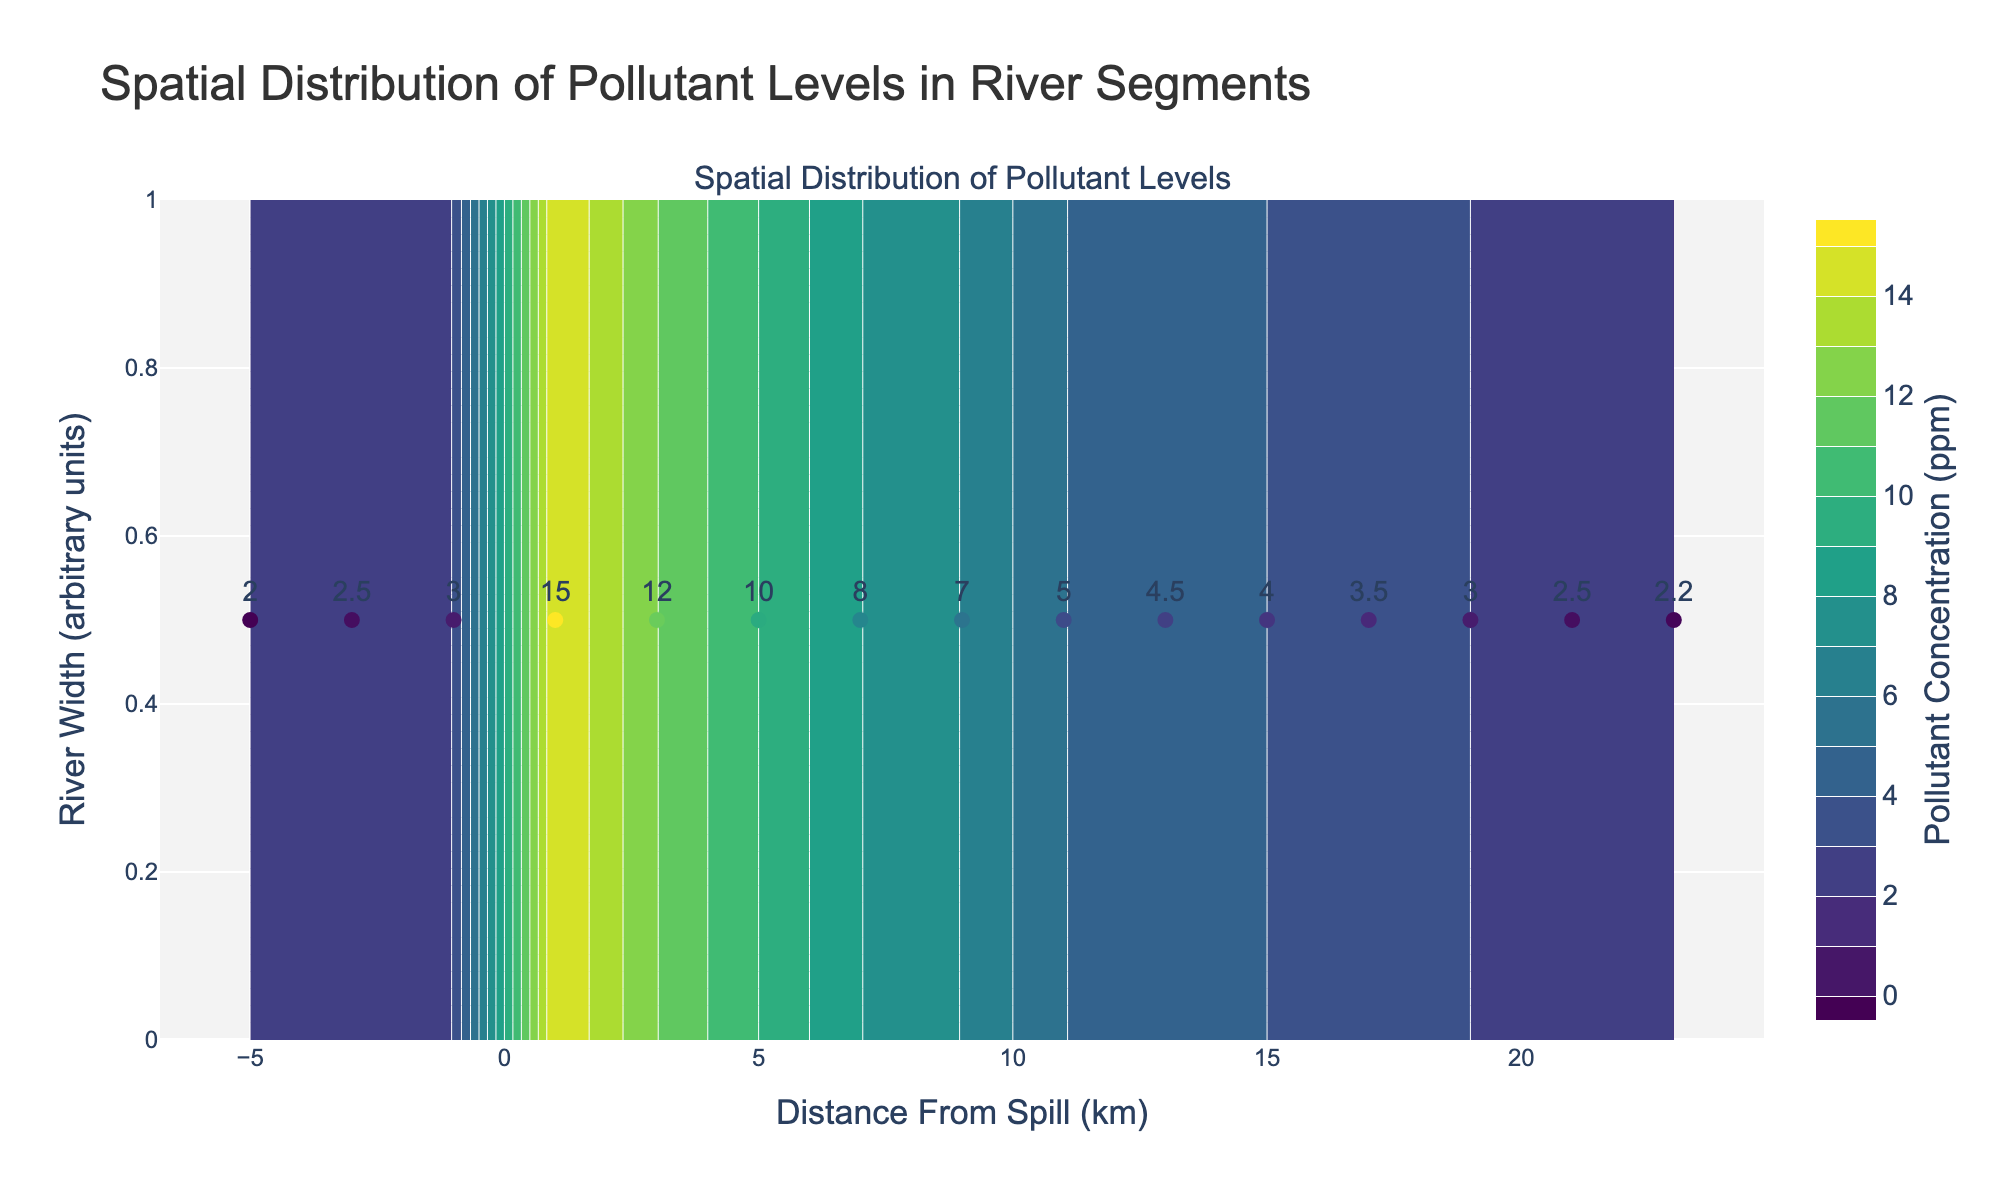What's the title of the plot? The title is prominently displayed at the top of the figure.
Answer: Spatial Distribution of Pollutant Levels in River Segments What is the highest pollutant concentration labelled in the figure? The highest labelled pollutant concentration can be identified by checking the text labels on the scatter plot points.
Answer: 15 ppm Where is the spill location marked on the plot? The spill location is indicated by the annotation near the center and top of the x-axis with the label 'Spill Location' and an arrow pointing to the corresponding location on the plot.
Answer: At 0 km How does the pollutant concentration change as the distance from the spill increases? Observing the scatter points and contour lines, the pollutant concentration decreases as the distance from the spill increases.
Answer: Decreases Which data point has the lowest pollutant concentration downstream? The data points downstream can be identified by their position to the right of the spill. The lowest label among these points indicates the lowest concentration.
Answer: Downstream_12 Comparing data points at distances -5 km, 3 km, and 15 km, which has the highest pollutant concentration? Checking the labelled values of the points at -5 km (Upstream_1: 2 ppm), 3 km (Downstream_2: 12 ppm), and 15 km (Downstream_8: 4 ppm), the highest concentration is at 3 km.
Answer: 3 km At what distance from the spill does the pollutant concentration drop below 5 ppm? By examining the scatter plot labels and interpolated contour lines, we note that the concentration drops below 5 ppm between 11 km and 15 km downstream from the spill.
Answer: 11-15 km What is the range of pollutant concentrations represented by the color gradient in the contour plot? The color gradient in the contour plot, as indicated by the colorbar, ranges from the lowest concentration to the highest concentration.
Answer: 0 ppm to 15 ppm Which segment, upstream or downstream, shows higher pollutant concentrations overall? Looking at the labels and the contour plot, the downstream segments show significantly higher pollutant concentrations compared to the upstream segments.
Answer: Downstream How many upstream and downstream segments are shown in the plot? The upstream segments are located to the left of the spill location (0 km), and the downstream segments are to the right. By counting these, there are 3 upstream and 12 downstream segments.
Answer: 3 upstream, 12 downstream 